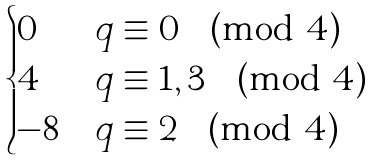Convert formula to latex. <formula><loc_0><loc_0><loc_500><loc_500>\begin{cases} 0 & q \equiv 0 \pmod { 4 } \\ 4 & q \equiv 1 , 3 \pmod { 4 } \\ - 8 & q \equiv 2 \pmod { 4 } \\ \end{cases}</formula> 